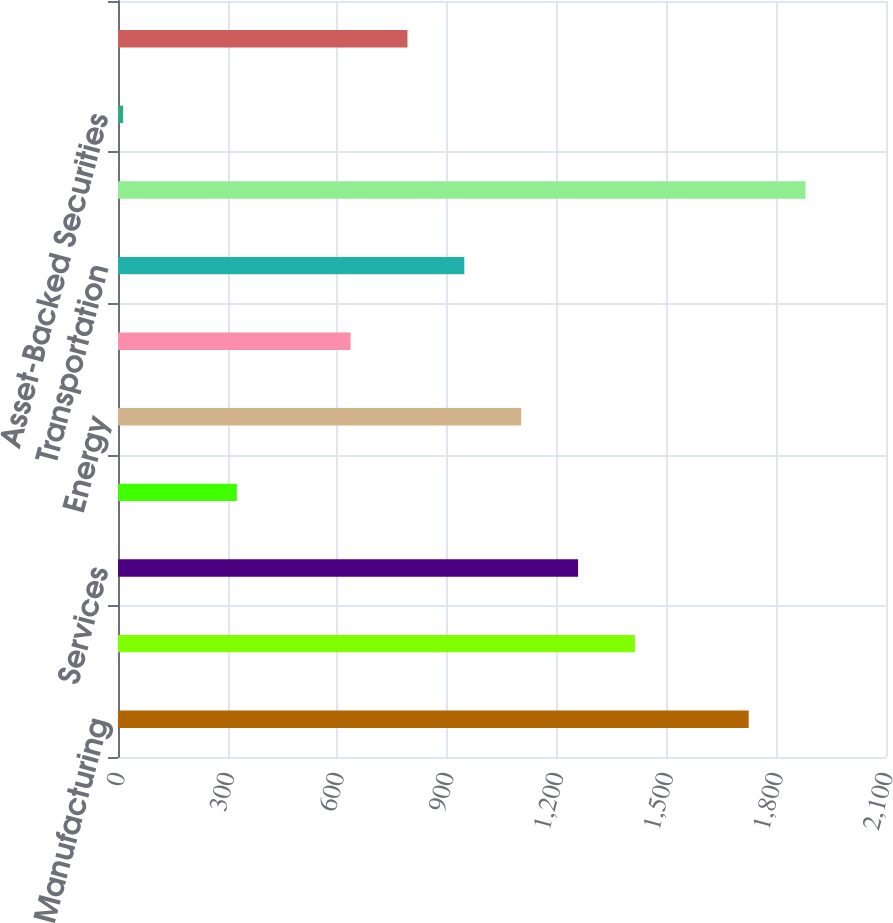<chart> <loc_0><loc_0><loc_500><loc_500><bar_chart><fcel>Manufacturing<fcel>Utilities<fcel>Services<fcel>Finance<fcel>Energy<fcel>Retail and Wholesale<fcel>Transportation<fcel>Total Corporate Securities<fcel>Asset-Backed Securities<fcel>Residential Mortgage Backed<nl><fcel>1724.5<fcel>1413.5<fcel>1258<fcel>325<fcel>1102.5<fcel>636<fcel>947<fcel>1880<fcel>14<fcel>791.5<nl></chart> 